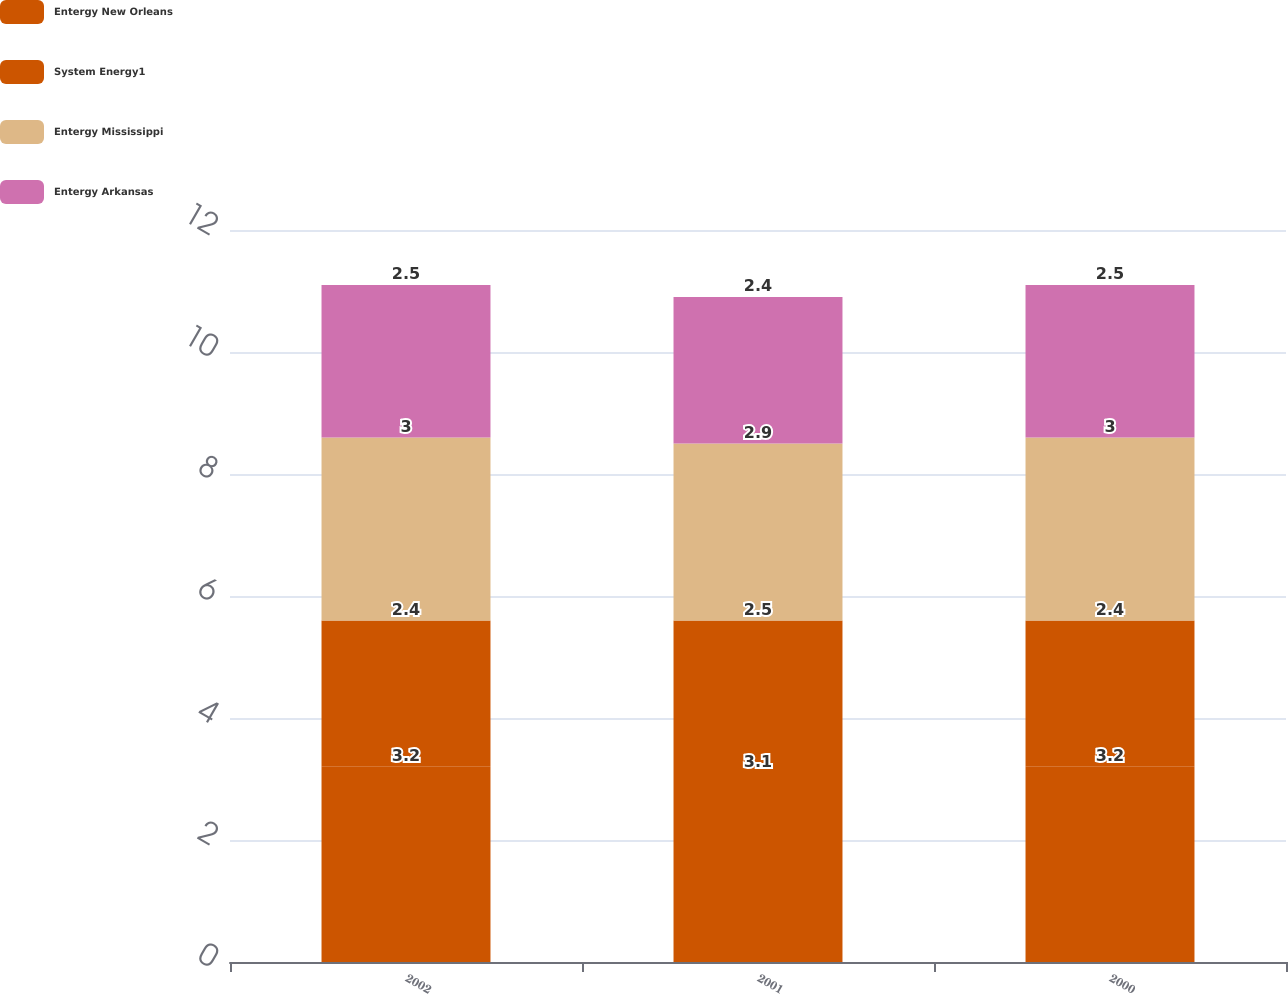Convert chart. <chart><loc_0><loc_0><loc_500><loc_500><stacked_bar_chart><ecel><fcel>2002<fcel>2001<fcel>2000<nl><fcel>Entergy New Orleans<fcel>3.2<fcel>3.1<fcel>3.2<nl><fcel>System Energy1<fcel>2.4<fcel>2.5<fcel>2.4<nl><fcel>Entergy Mississippi<fcel>3<fcel>2.9<fcel>3<nl><fcel>Entergy Arkansas<fcel>2.5<fcel>2.4<fcel>2.5<nl></chart> 